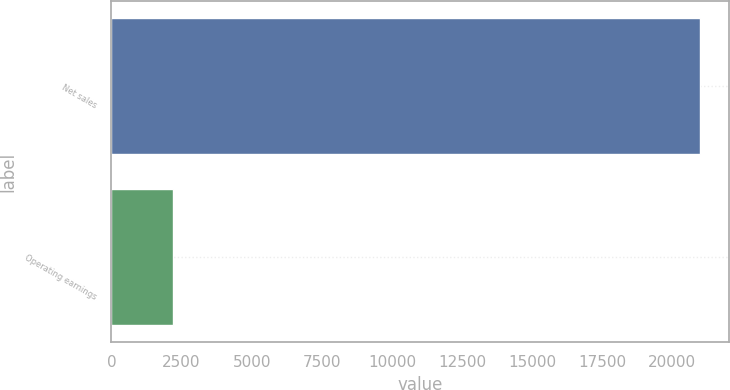Convert chart to OTSL. <chart><loc_0><loc_0><loc_500><loc_500><bar_chart><fcel>Net sales<fcel>Operating earnings<nl><fcel>20975<fcel>2179<nl></chart> 